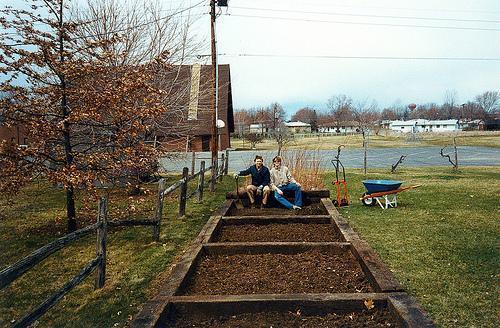How many people are visible?
Give a very brief answer. 2. How many cats are shown?
Give a very brief answer. 0. How many electric poles are shown?
Give a very brief answer. 2. 